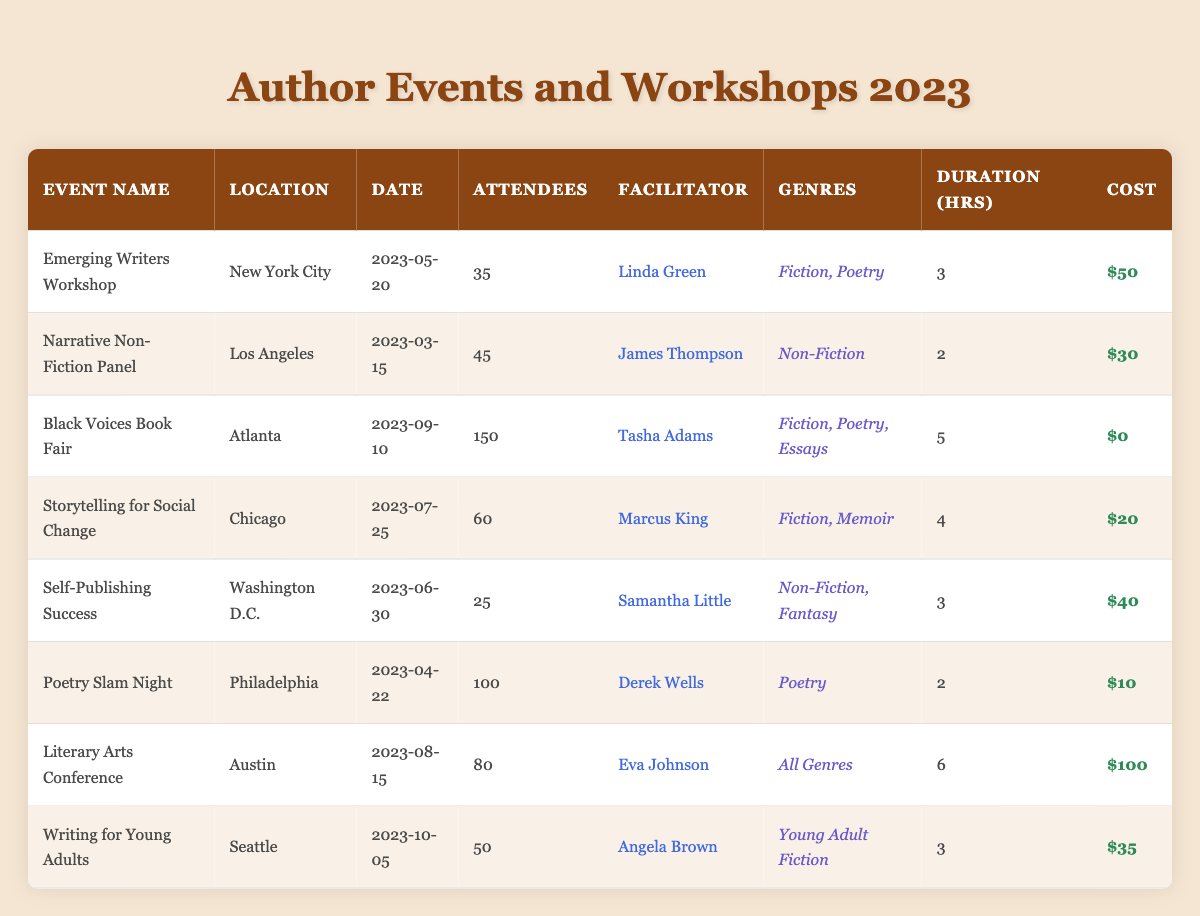What's the total number of attendees across all events? To find the total number of attendees, sum the attendees from each event: 35 + 45 + 150 + 60 + 25 + 100 + 80 + 50 = 545.
Answer: 545 Which event had the highest number of attendees? From the table, the event with the highest attendees is the "Black Voices Book Fair" with 150 attendees.
Answer: Black Voices Book Fair What is the average cost of attending an event? To calculate the average cost, sum the costs: 50 + 30 + 0 + 20 + 40 + 10 + 100 + 35 = 285. Since there are 8 events, the average cost is 285/8 = 35.625.
Answer: 35.625 How many events were facilitated by women? The events facilitated by women are: "Emerging Writers Workshop," "Black Voices Book Fair," "Storytelling for Social Change," "Self-Publishing Success," "Poetry Slam Night," "Literary Arts Conference," and "Writing for Young Adults." This totals to 6 events.
Answer: 6 Was there any event that did not have a cost? The "Black Voices Book Fair" had no cost listed (cost = 0), therefore, there is indeed an event without cost.
Answer: Yes What is the difference between the highest and lowest event costs? The highest cost is $100 (Literary Arts Conference) and the lowest is $0 (Black Voices Book Fair). The difference is 100 - 0 = 100.
Answer: 100 Which location hosted the most events? Counting the locations from the table: New York City (1), Los Angeles (1), Atlanta (1), Chicago (1), Washington D.C. (1), Philadelphia (1), Austin (1), Seattle (1). Each location hosted 1 event, so no location stands out as having the most.
Answer: All locations hosted 1 event How many genres were featured during the "Literary Arts Conference"? The "Literary Arts Conference" featured "All Genres," indicating that it included multiple genres. Based on the naming, it can be interpreted as a variety, but it is not specified how many exactly.
Answer: All Genres What was the total duration of all events combined? To find the total duration, sum the duration from each event: 3 + 2 + 5 + 4 + 3 + 2 + 6 + 3 = 28 hours.
Answer: 28 hours Which event occurred last in 2023? The event that occurred last in 2023 is "Writing for Young Adults," which was held on October 5, 2023.
Answer: Writing for Young Adults 